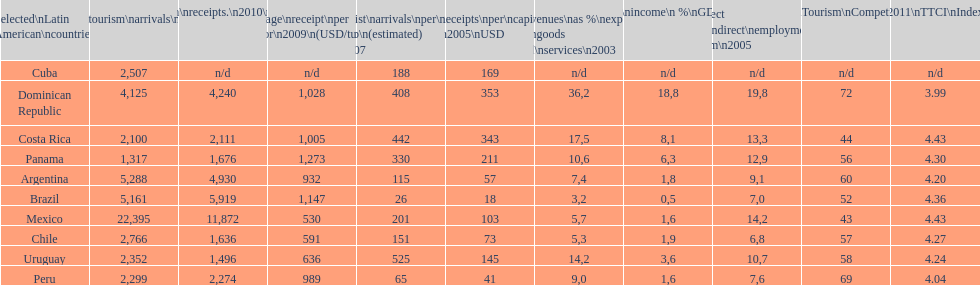What country makes the most tourist income? Dominican Republic. 